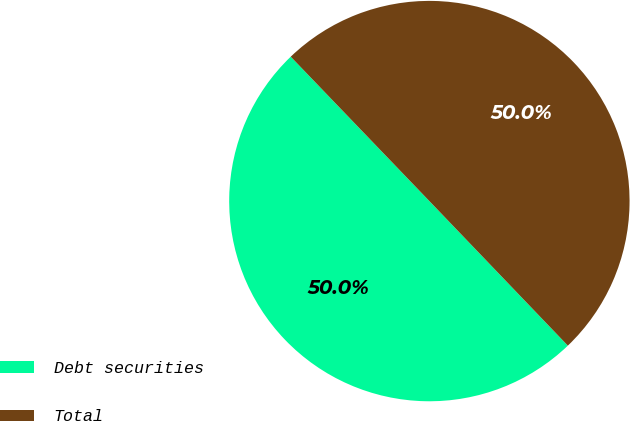Convert chart. <chart><loc_0><loc_0><loc_500><loc_500><pie_chart><fcel>Debt securities<fcel>Total<nl><fcel>49.98%<fcel>50.02%<nl></chart> 